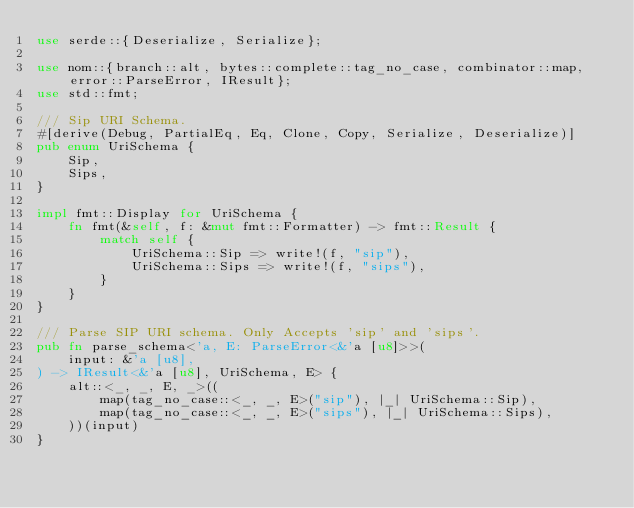Convert code to text. <code><loc_0><loc_0><loc_500><loc_500><_Rust_>use serde::{Deserialize, Serialize};

use nom::{branch::alt, bytes::complete::tag_no_case, combinator::map, error::ParseError, IResult};
use std::fmt;

/// Sip URI Schema.
#[derive(Debug, PartialEq, Eq, Clone, Copy, Serialize, Deserialize)]
pub enum UriSchema {
    Sip,
    Sips,
}

impl fmt::Display for UriSchema {
    fn fmt(&self, f: &mut fmt::Formatter) -> fmt::Result {
        match self {
            UriSchema::Sip => write!(f, "sip"),
            UriSchema::Sips => write!(f, "sips"),
        }
    }
}

/// Parse SIP URI schema. Only Accepts 'sip' and 'sips'.
pub fn parse_schema<'a, E: ParseError<&'a [u8]>>(
    input: &'a [u8],
) -> IResult<&'a [u8], UriSchema, E> {
    alt::<_, _, E, _>((
        map(tag_no_case::<_, _, E>("sip"), |_| UriSchema::Sip),
        map(tag_no_case::<_, _, E>("sips"), |_| UriSchema::Sips),
    ))(input)
}
</code> 